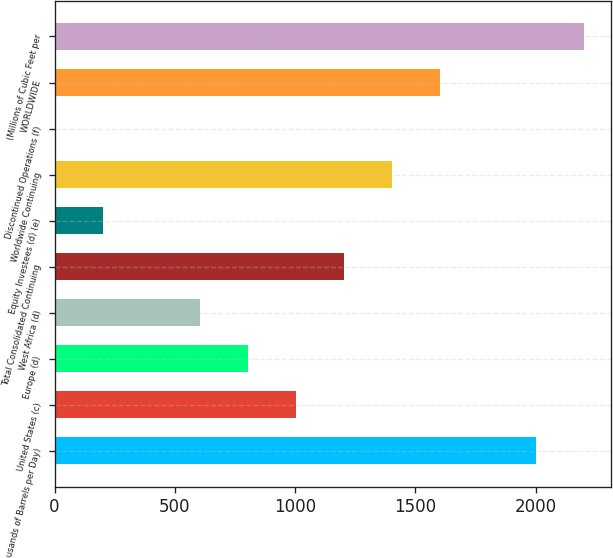<chart> <loc_0><loc_0><loc_500><loc_500><bar_chart><fcel>(Thousands of Barrels per Day)<fcel>United States (c)<fcel>Europe (d)<fcel>West Africa (d)<fcel>Total Consolidated Continuing<fcel>Equity Investees (d) (e)<fcel>Worldwide Continuing<fcel>Discontinued Operations (f)<fcel>WORLDWIDE<fcel>(Millions of Cubic Feet per<nl><fcel>2003<fcel>1003<fcel>803<fcel>603<fcel>1203<fcel>203<fcel>1403<fcel>3<fcel>1603<fcel>2203<nl></chart> 